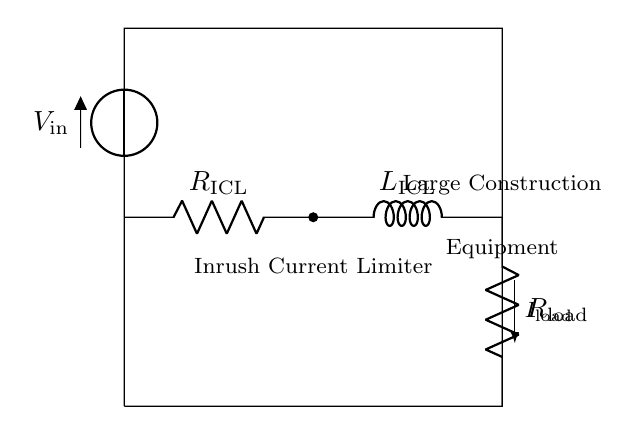What components are included in the circuit? The circuit includes a voltage source, a resistor, an inductor, and a load resistor, which are depicted in the diagram.
Answer: voltage source, resistor, inductor, load resistor What does the abbreviation ICL stand for in this circuit? ICL stands for Inrush Current Limiter, which is indicated in the circuit diagram by the label next to the resistor and inductor group.
Answer: Inrush Current Limiter What is the purpose of the inductor in this circuit? The inductor in this circuit limits the inrush current when large construction equipment is powered on, allowing the current to ramp up gradually instead of surging.
Answer: Limit inrush current What is the effect of the resistor labeled R_load? The resistor labeled R_load represents the load of the large construction equipment and affects the overall current flowing through the circuit, with the resistance determining how much load is applied.
Answer: Determines load current How does the presence of the inductor affect the circuit behavior during startup? The inductor causes a delay in the build-up of current due to its property of opposing changes in current, leading to a smoother startup as opposed to an instantaneous surge, which could damage components.
Answer: Smoother startup What happens to the inrush current if the resistance is increased? Increasing the resistance will reduce the inrush current, as higher resistance restricts the current flow according to Ohm's law, thus resulting in a lower peak current during startup.
Answer: Inrush current decreases 